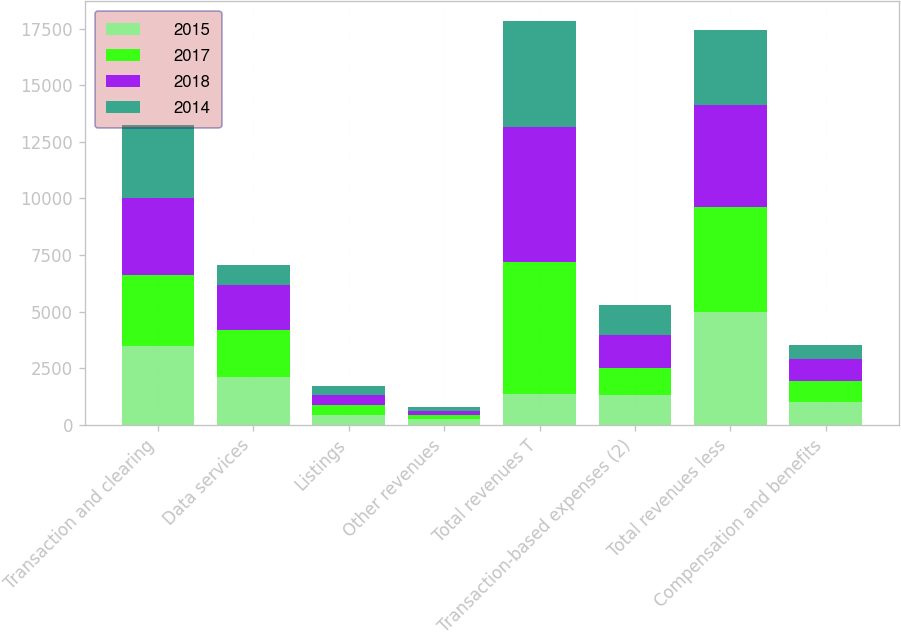<chart> <loc_0><loc_0><loc_500><loc_500><stacked_bar_chart><ecel><fcel>Transaction and clearing<fcel>Data services<fcel>Listings<fcel>Other revenues<fcel>Total revenues T<fcel>Transaction-based expenses (2)<fcel>Total revenues less<fcel>Compensation and benefits<nl><fcel>2015<fcel>3483<fcel>2115<fcel>444<fcel>234<fcel>1344<fcel>1297<fcel>4979<fcel>994<nl><fcel>2017<fcel>3131<fcel>2084<fcel>426<fcel>202<fcel>5843<fcel>1205<fcel>4638<fcel>946<nl><fcel>2018<fcel>3384<fcel>1978<fcel>432<fcel>177<fcel>5971<fcel>1459<fcel>4512<fcel>953<nl><fcel>2014<fcel>3228<fcel>871<fcel>405<fcel>178<fcel>4682<fcel>1344<fcel>3338<fcel>611<nl></chart> 